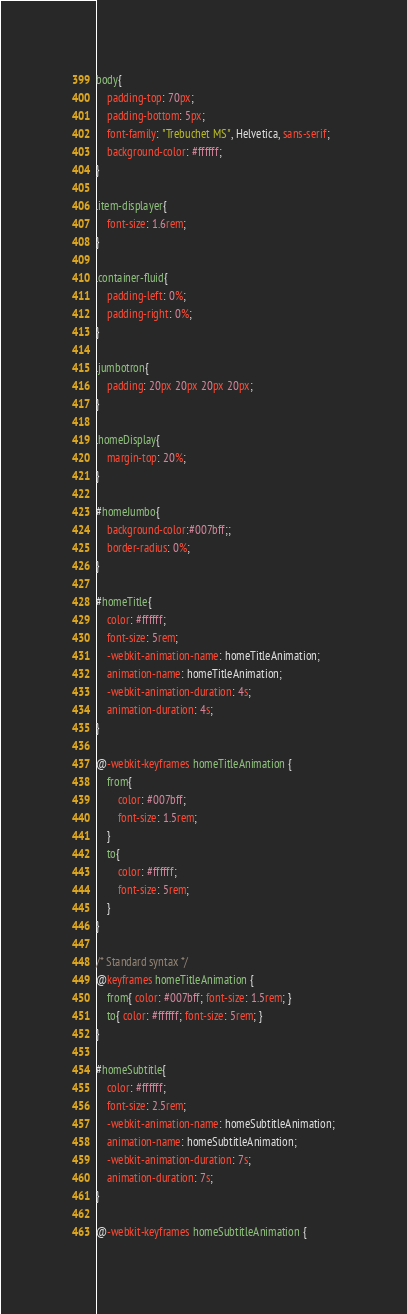Convert code to text. <code><loc_0><loc_0><loc_500><loc_500><_CSS_>body{
    padding-top: 70px;
    padding-bottom: 5px;
    font-family: "Trebuchet MS", Helvetica, sans-serif;
    background-color: #ffffff;
}

.item-displayer{
    font-size: 1.6rem;
}

.container-fluid{
    padding-left: 0%;
    padding-right: 0%;
}

.jumbotron{
    padding: 20px 20px 20px 20px;
}

.homeDisplay{
    margin-top: 20%;
}

#homeJumbo{
    background-color:#007bff;;
    border-radius: 0%;
}

#homeTitle{
    color: #ffffff;
    font-size: 5rem;
    -webkit-animation-name: homeTitleAnimation;
    animation-name: homeTitleAnimation;    
    -webkit-animation-duration: 4s;
    animation-duration: 4s;
}

@-webkit-keyframes homeTitleAnimation {
    from{
        color: #007bff;
        font-size: 1.5rem;
    }
    to{
        color: #ffffff;
        font-size: 5rem;
    }
}

/* Standard syntax */
@keyframes homeTitleAnimation {
    from{ color: #007bff; font-size: 1.5rem; }
    to{ color: #ffffff; font-size: 5rem; }
}

#homeSubtitle{
    color: #ffffff;
    font-size: 2.5rem;
    -webkit-animation-name: homeSubtitleAnimation;
    animation-name: homeSubtitleAnimation;    
    -webkit-animation-duration: 7s;
    animation-duration: 7s;
}

@-webkit-keyframes homeSubtitleAnimation {</code> 